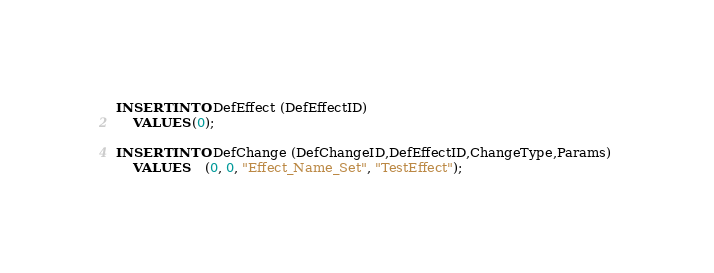<code> <loc_0><loc_0><loc_500><loc_500><_SQL_>INSERT INTO DefEffect (DefEffectID) 
	VALUES (0);

INSERT INTO DefChange (DefChangeID,DefEffectID,ChangeType,Params) 
	VALUES	(0, 0, "Effect_Name_Set", "TestEffect");</code> 